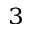<formula> <loc_0><loc_0><loc_500><loc_500>^ { 3 }</formula> 